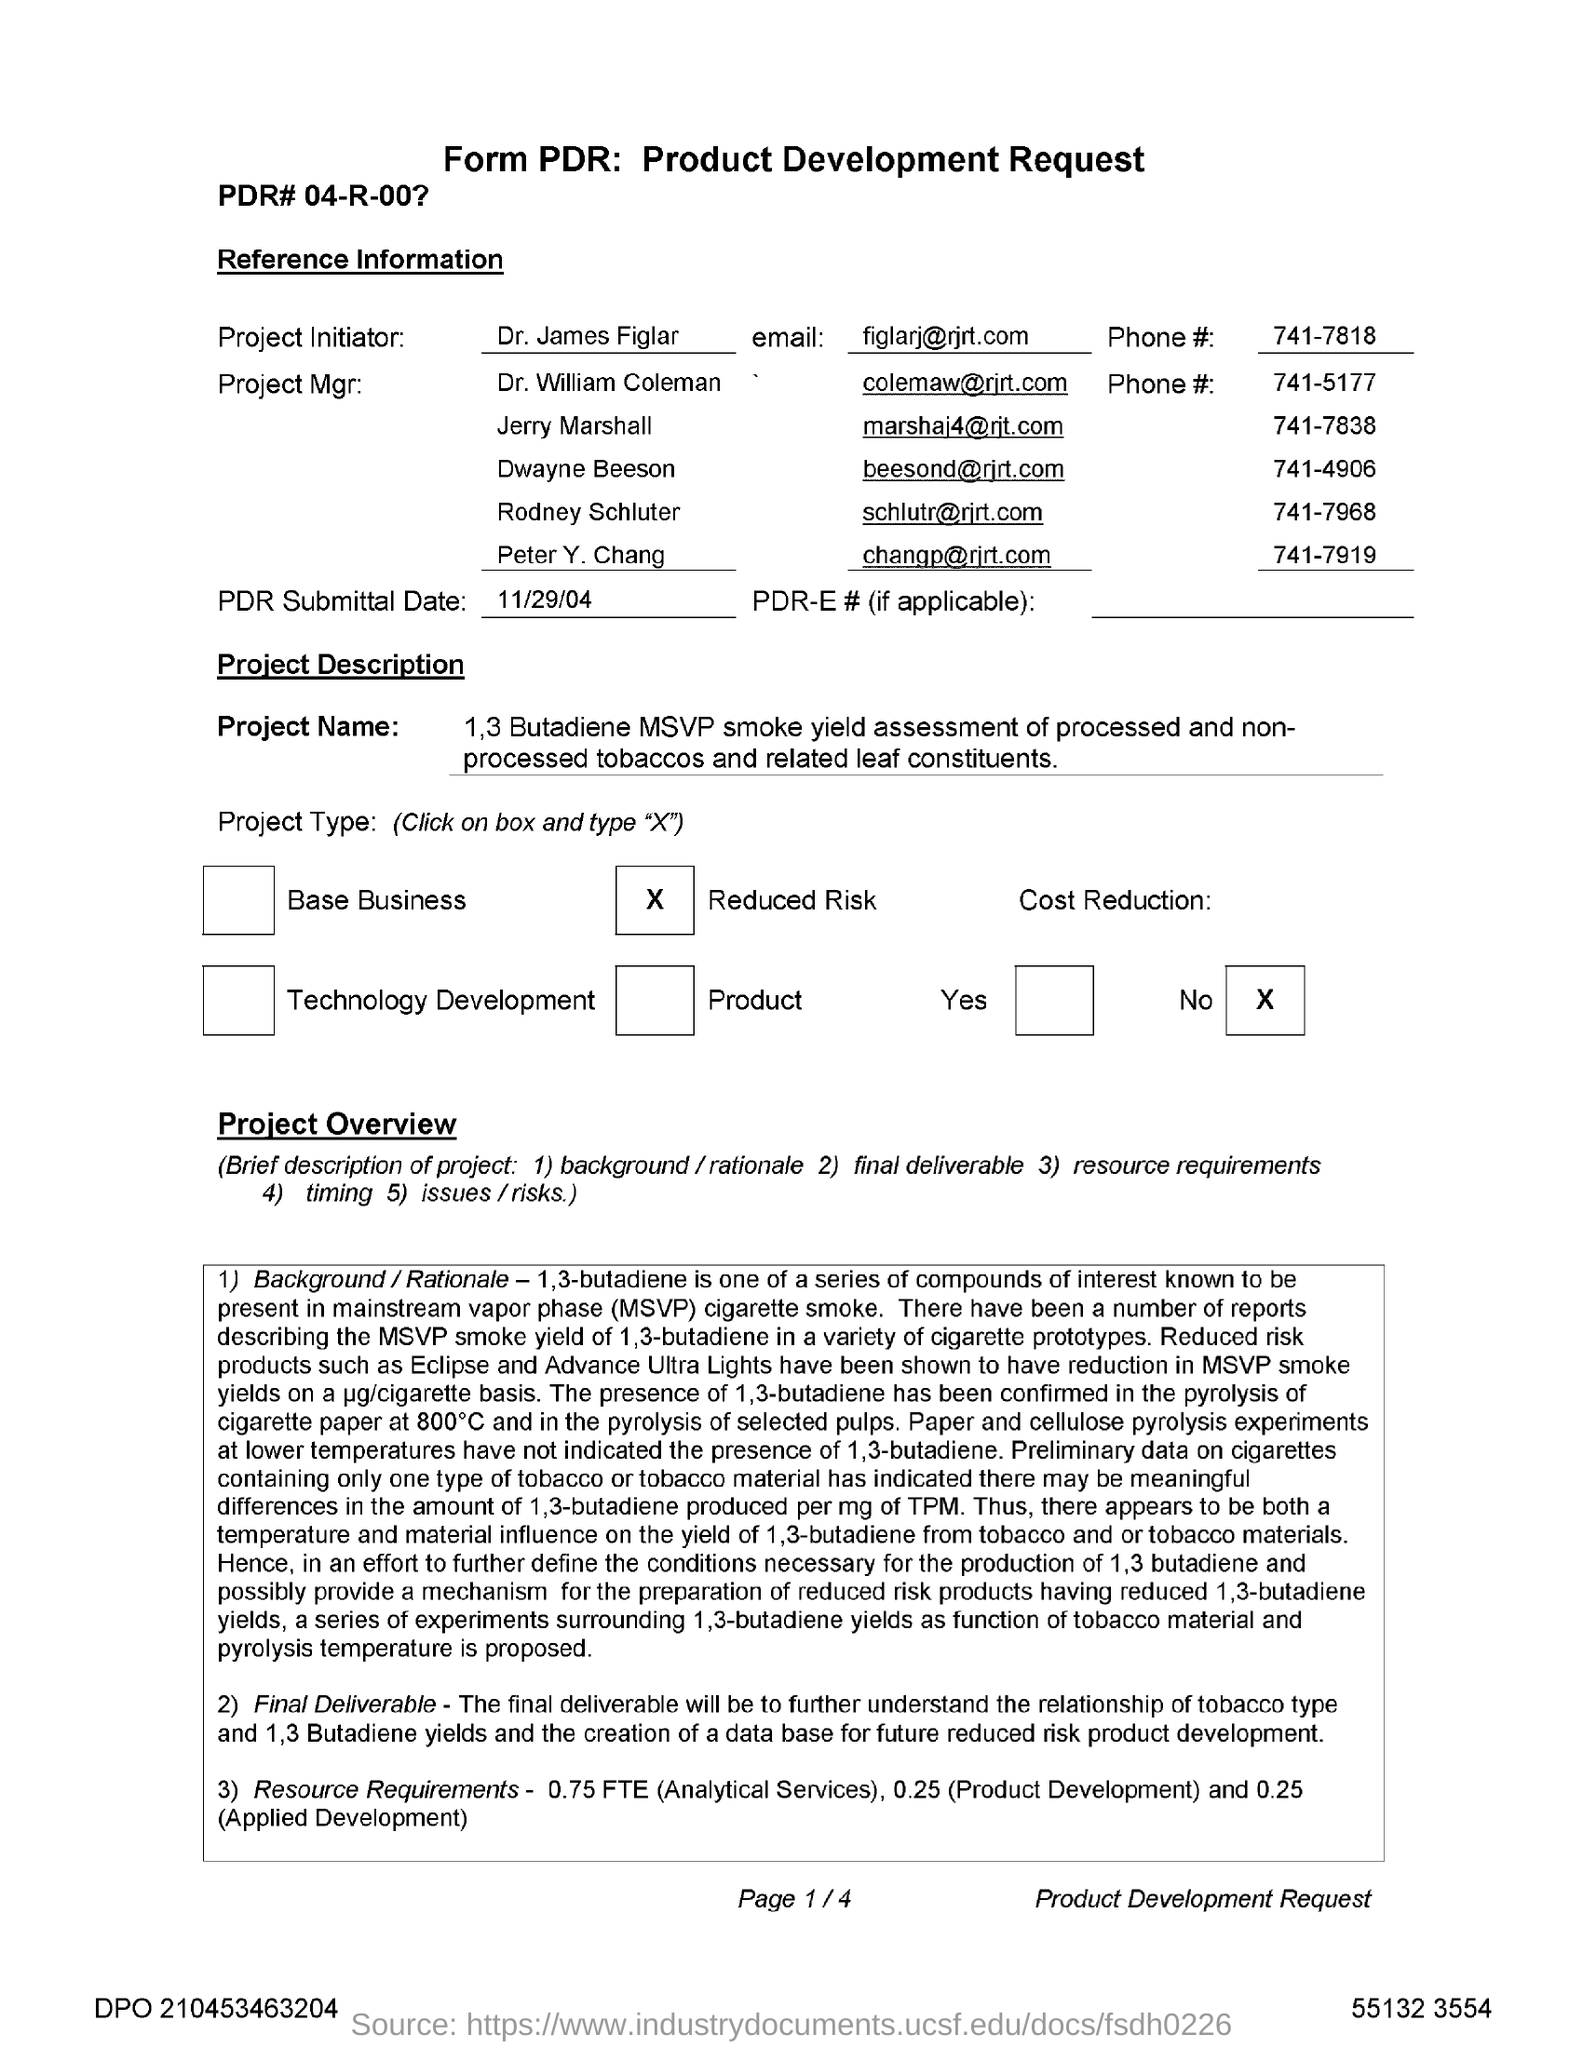Outline some significant characteristics in this image. The phone number for Dr. James Figlar is 741-7818. The PDR submittal date is 11/29/04. Dr. James Figlar is the initiator of the project. The email address for Dr. James Figlar is [figlarj@rjrt.com](mailto:figlarj@rjrt.com). 